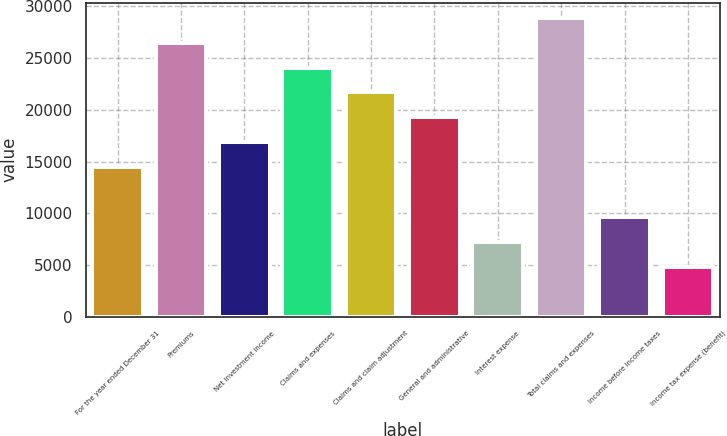Convert chart to OTSL. <chart><loc_0><loc_0><loc_500><loc_500><bar_chart><fcel>For the year ended December 31<fcel>Premiums<fcel>Net investment income<fcel>Claims and expenses<fcel>Claims and claim adjustment<fcel>General and administrative<fcel>Interest expense<fcel>Total claims and expenses<fcel>Income before income taxes<fcel>Income tax expense (benefit)<nl><fcel>14457.7<fcel>26503<fcel>16866.8<fcel>24094<fcel>21684.9<fcel>19275.8<fcel>7230.54<fcel>28912.1<fcel>9639.6<fcel>4821.48<nl></chart> 